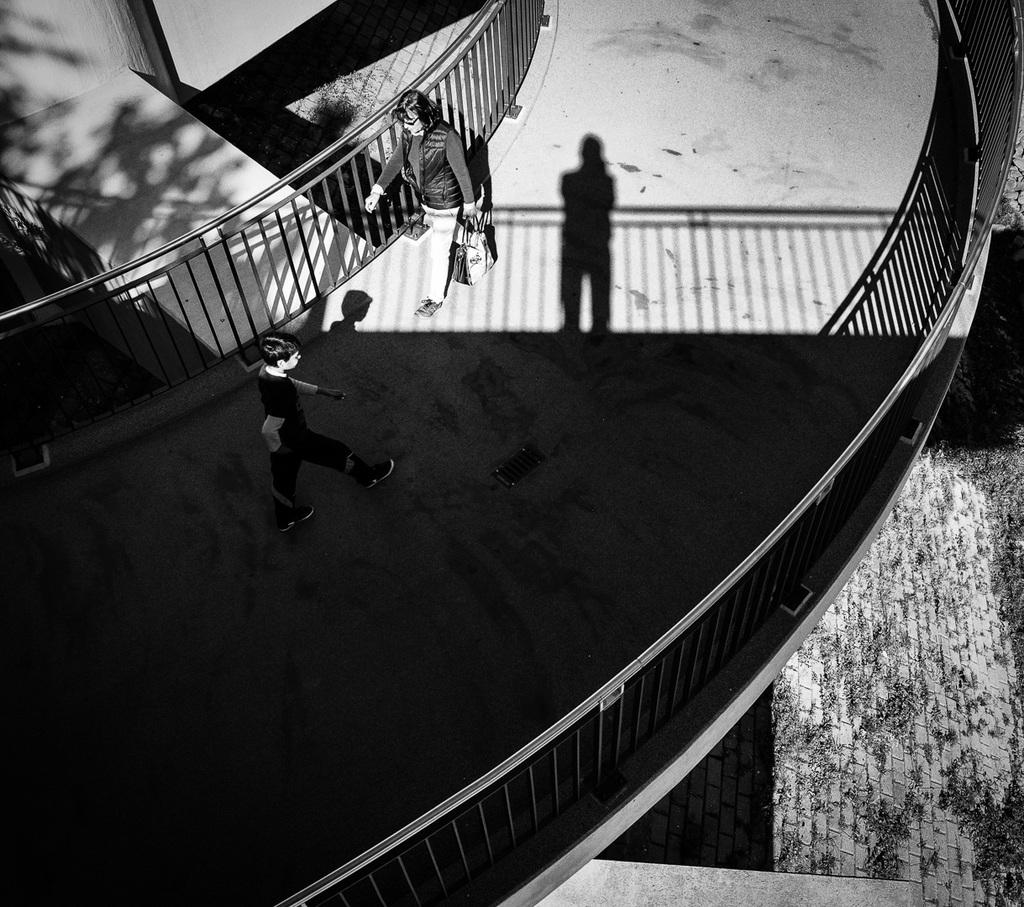Who or what is present in the image? There are people in the image. What are the people doing in the image? The people are walking. What can be seen in the background or surrounding the people? There is a fence in the image. What is the color scheme of the image? The image is black and white. What type of spoon is being used by the people in the image? There is no spoon present in the image; the people are walking. What kind of insurance policy is being discussed by the people in the image? There is no discussion of insurance in the image; the people are walking. 